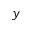<formula> <loc_0><loc_0><loc_500><loc_500>y</formula> 